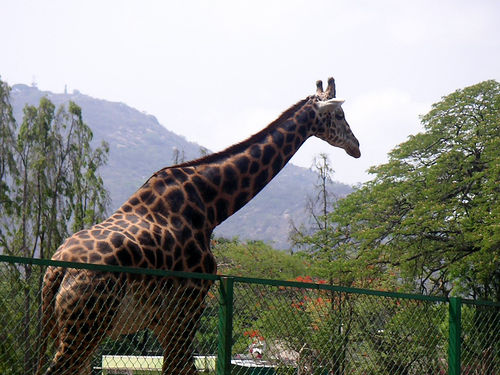Could you tell me more about giraffes' diet and how it relates to their habitat? Giraffes are herbivores and their diet primarily consists of leaves, flowers, and fruits. They have a preference for acacia species and use their long necks to reach high into trees. The environment shown behind the giraffe, with its trees and foliage, is ideal for them to forage for food. 